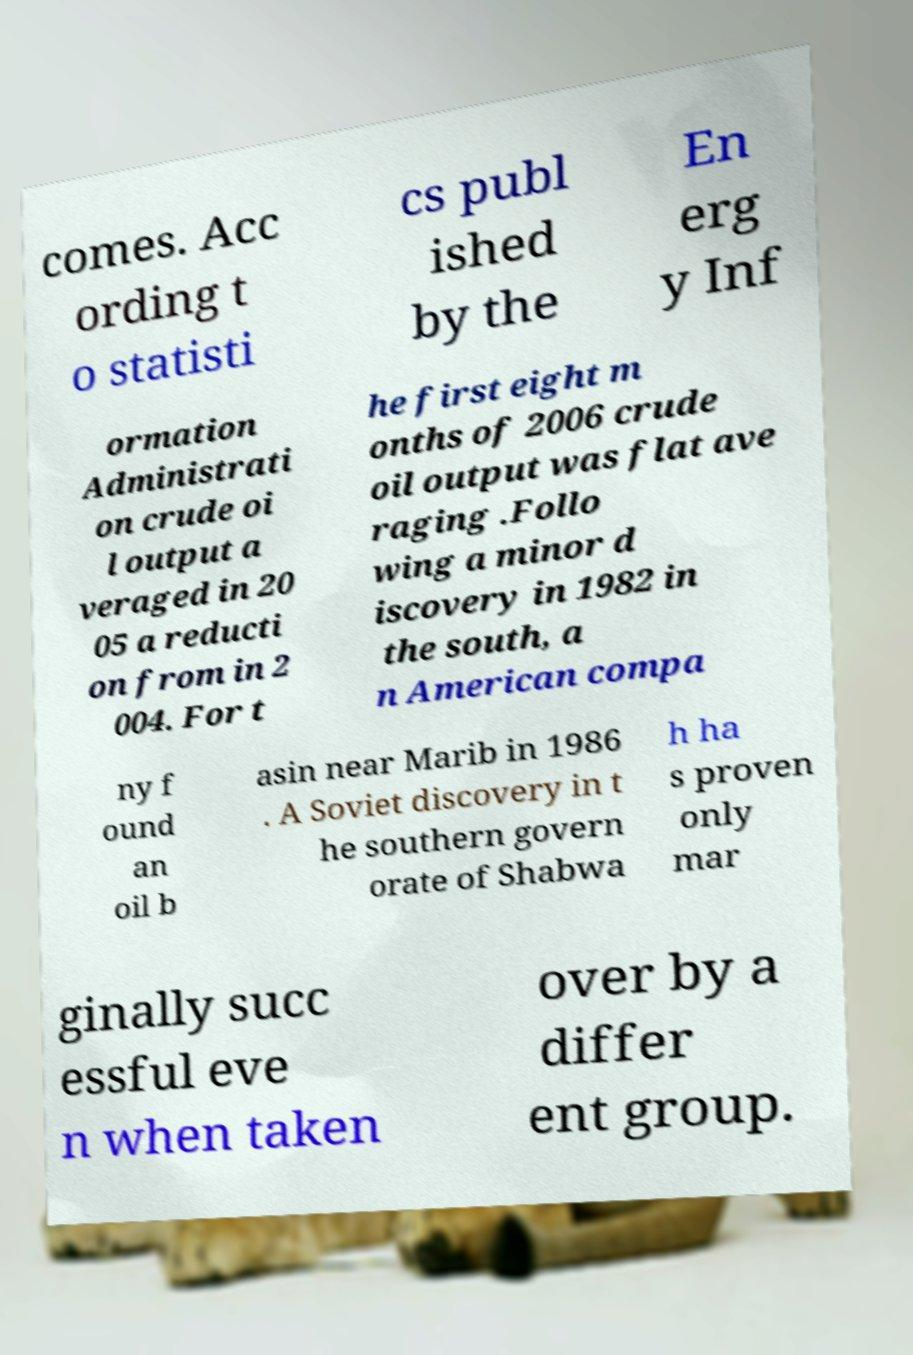Please identify and transcribe the text found in this image. comes. Acc ording t o statisti cs publ ished by the En erg y Inf ormation Administrati on crude oi l output a veraged in 20 05 a reducti on from in 2 004. For t he first eight m onths of 2006 crude oil output was flat ave raging .Follo wing a minor d iscovery in 1982 in the south, a n American compa ny f ound an oil b asin near Marib in 1986 . A Soviet discovery in t he southern govern orate of Shabwa h ha s proven only mar ginally succ essful eve n when taken over by a differ ent group. 